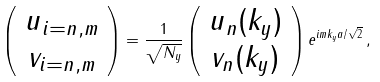<formula> <loc_0><loc_0><loc_500><loc_500>\left ( \begin{array} { c } u _ { { i } = n , m } \\ v _ { { i } = n , m } \end{array} \right ) = \frac { 1 } { \sqrt { N _ { y } } } \left ( \begin{array} { c } u _ { n } ( k _ { y } ) \\ v _ { n } ( k _ { y } ) \end{array} \right ) e ^ { i m k _ { y } a / \sqrt { 2 } } \, ,</formula> 